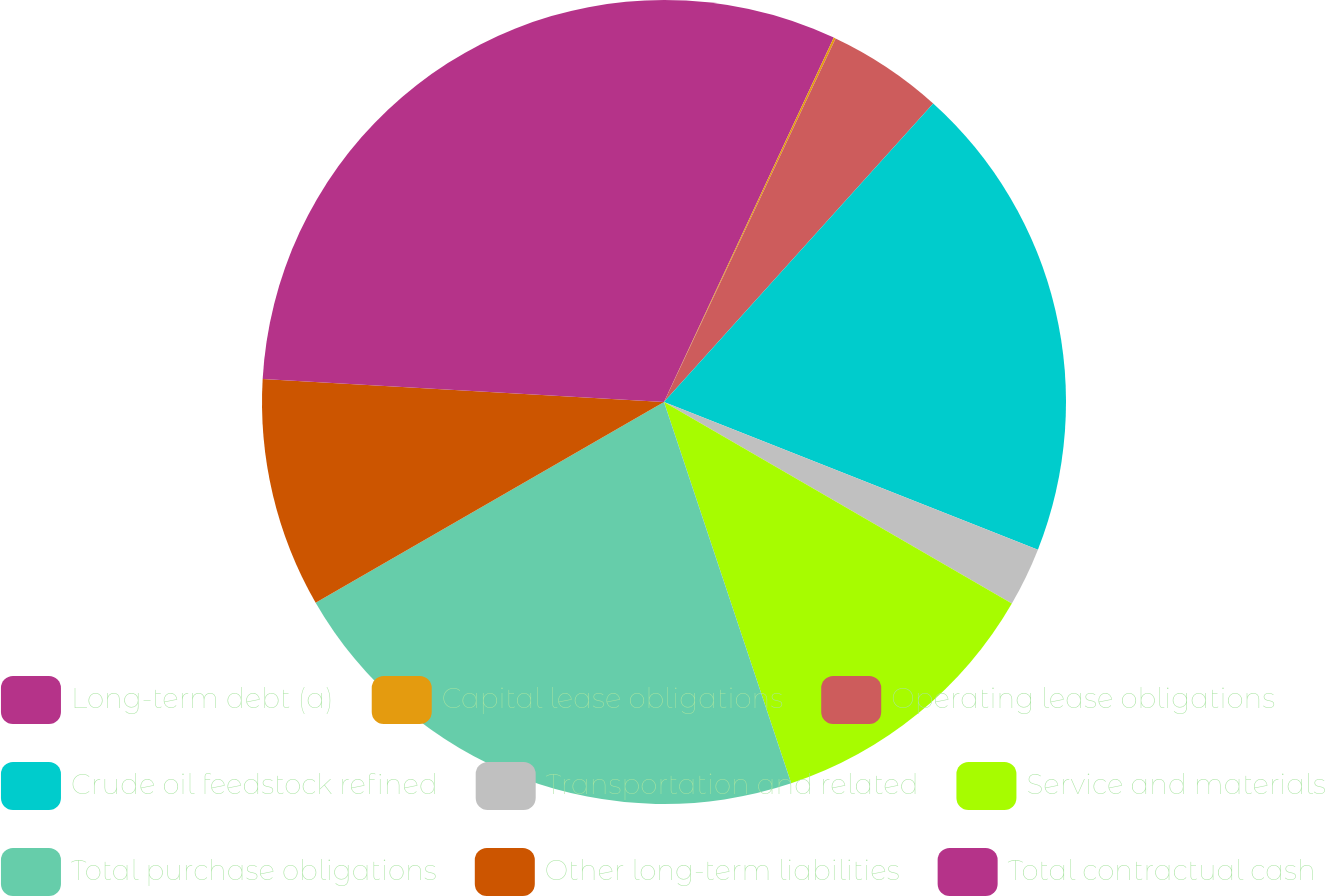Convert chart to OTSL. <chart><loc_0><loc_0><loc_500><loc_500><pie_chart><fcel>Long-term debt (a)<fcel>Capital lease obligations<fcel>Operating lease obligations<fcel>Crude oil feedstock refined<fcel>Transportation and related<fcel>Service and materials<fcel>Total purchase obligations<fcel>Other long-term liabilities<fcel>Total contractual cash<nl><fcel>6.94%<fcel>0.08%<fcel>4.66%<fcel>19.31%<fcel>2.37%<fcel>11.52%<fcel>21.81%<fcel>9.23%<fcel>24.09%<nl></chart> 